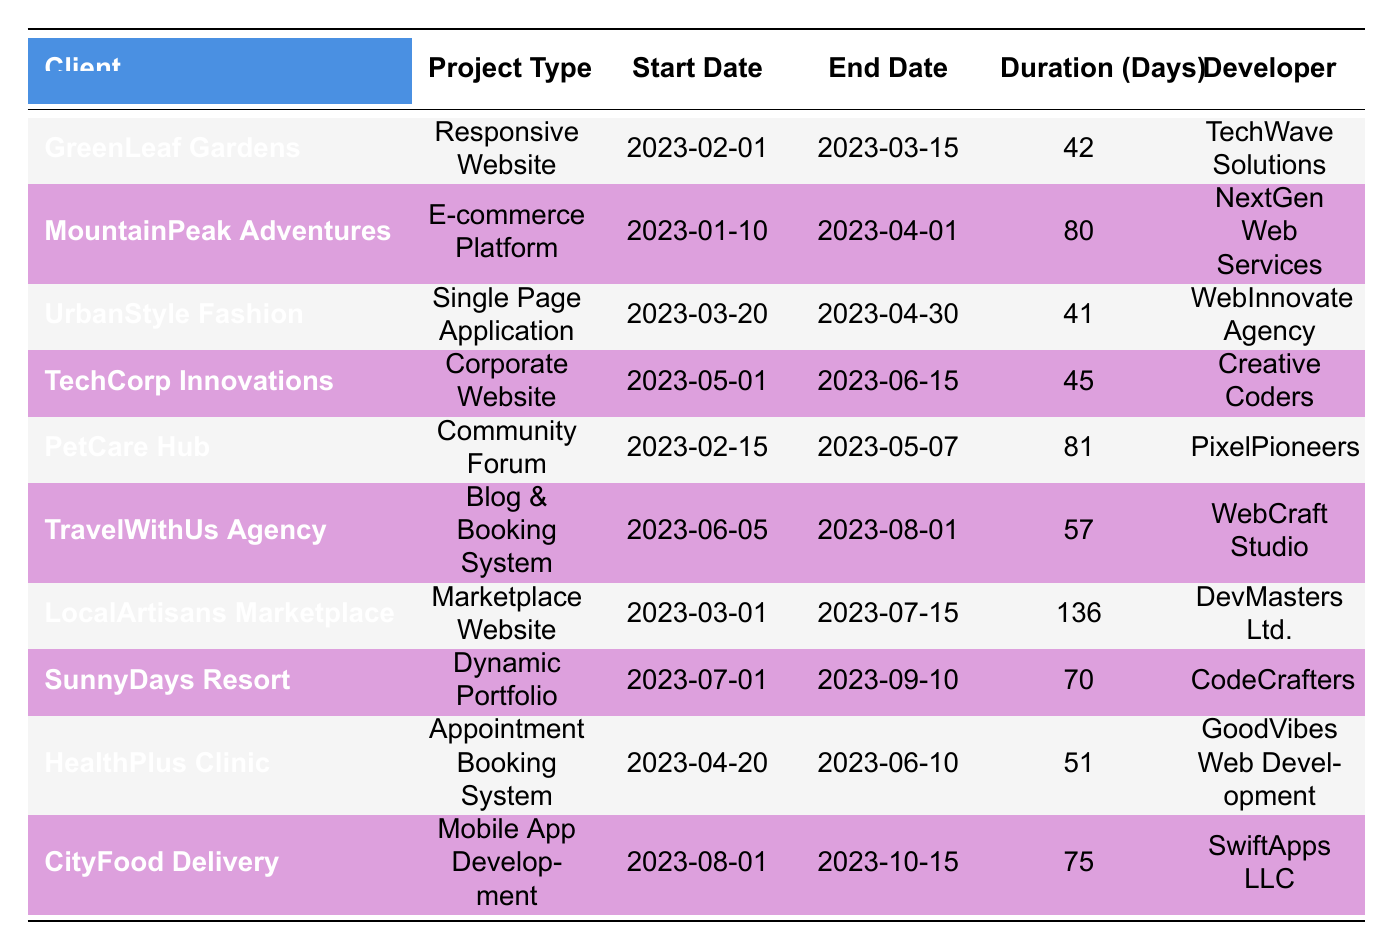What is the duration of the project for GreenLeaf Gardens? The duration for the project listed under GreenLeaf Gardens is 42 days, as shown in the Duration (Days) column for that specific client entry.
Answer: 42 days Which project has the longest duration? The project with the longest duration is the LocalArtisans Marketplace, with a total of 136 days, compared to the other entries in the Duration (Days) column.
Answer: 136 days Is the project for TravelWithUs Agency completed? No, the project for TravelWithUs Agency is marked as In Progress, indicating that it has not been completed yet.
Answer: No How many projects were completed under the developer Creative Coders? There is one project listed under Creative Coders, which is the Corporate Website for TechCorp Innovations, as indicated in the relevant column of the table.
Answer: 1 What is the average duration of all completed projects? First, add up the durations of all completed projects: 42 + 80 + 41 + 45 + 81 + 51 = 340 days. There are 6 completed projects, so the average duration is 340 / 6 = 56.67 days.
Answer: 56.67 days Did any project start in March 2023 and complete it in April 2023? Yes, there are two projects that started in March and were completed in April: UrbanStyle Fashion and GreenLeaf Gardens, as each project falls within the specified date range.
Answer: Yes Which project had the earliest start date? The project with the earliest start date is for MountainPeak Adventures, which started on January 10, 2023, as seen in the Start Date column of the table.
Answer: January 10, 2023 How many total days did projects scheduled to complete by September 2023 take? All projects completed by September 2023 include: GreenLeaf Gardens (42 days), MountainPeak Adventures (80 days), UrbanStyle Fashion (41 days), TechCorp Innovations (45 days), PetCare Hub (81 days), and HealthPlus Clinic (51 days). Adding these gives a total of 42 + 80 + 41 + 45 + 81 + 51 = 340 days.
Answer: 340 days What percentage of the total projects listed are still in progress or upcoming? There are 3 projects still in progress (TravelWithUs Agency and LocalArtisans Marketplace) and 2 upcoming (SunnyDays Resort and CityFood Delivery), making a total of 5 out of 10 projects. The percentage is (5 / 10) * 100 = 50%.
Answer: 50% 